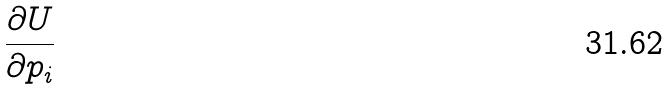Convert formula to latex. <formula><loc_0><loc_0><loc_500><loc_500>\frac { \partial U } { \partial p _ { i } }</formula> 